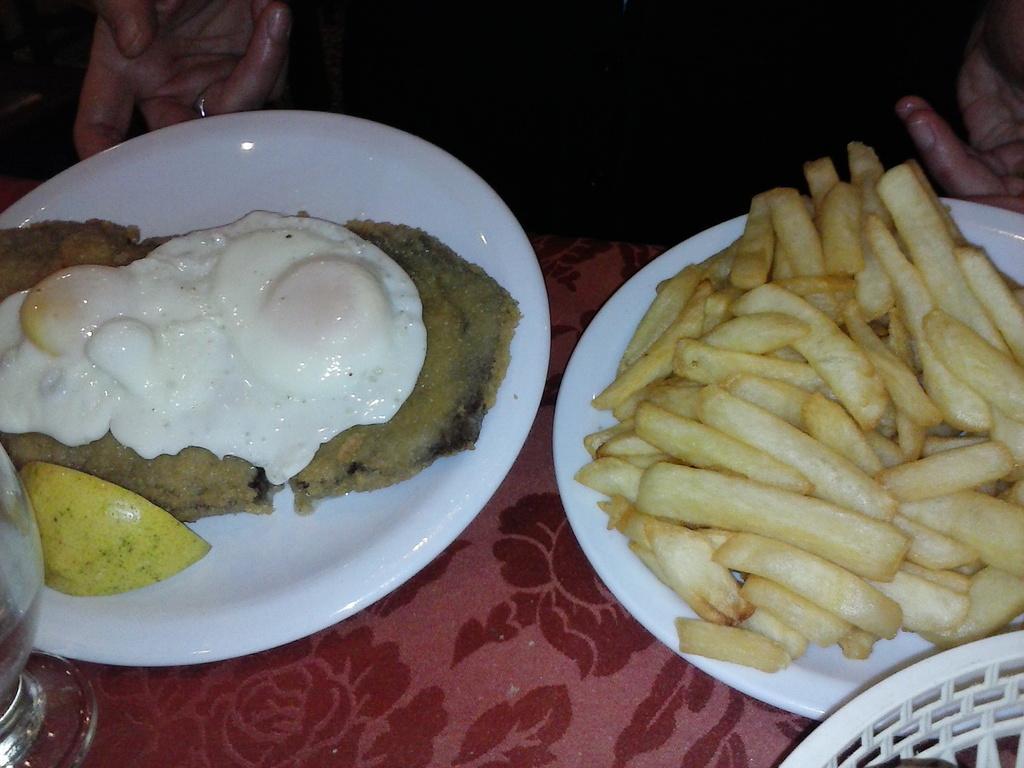In one or two sentences, can you explain what this image depicts? In this image we can see french fries is kept in white color plate and an omelet is kept in the other plate. Left bottom of the image glass is there on red color surface. Top right and left sides of the image human hands are present. 